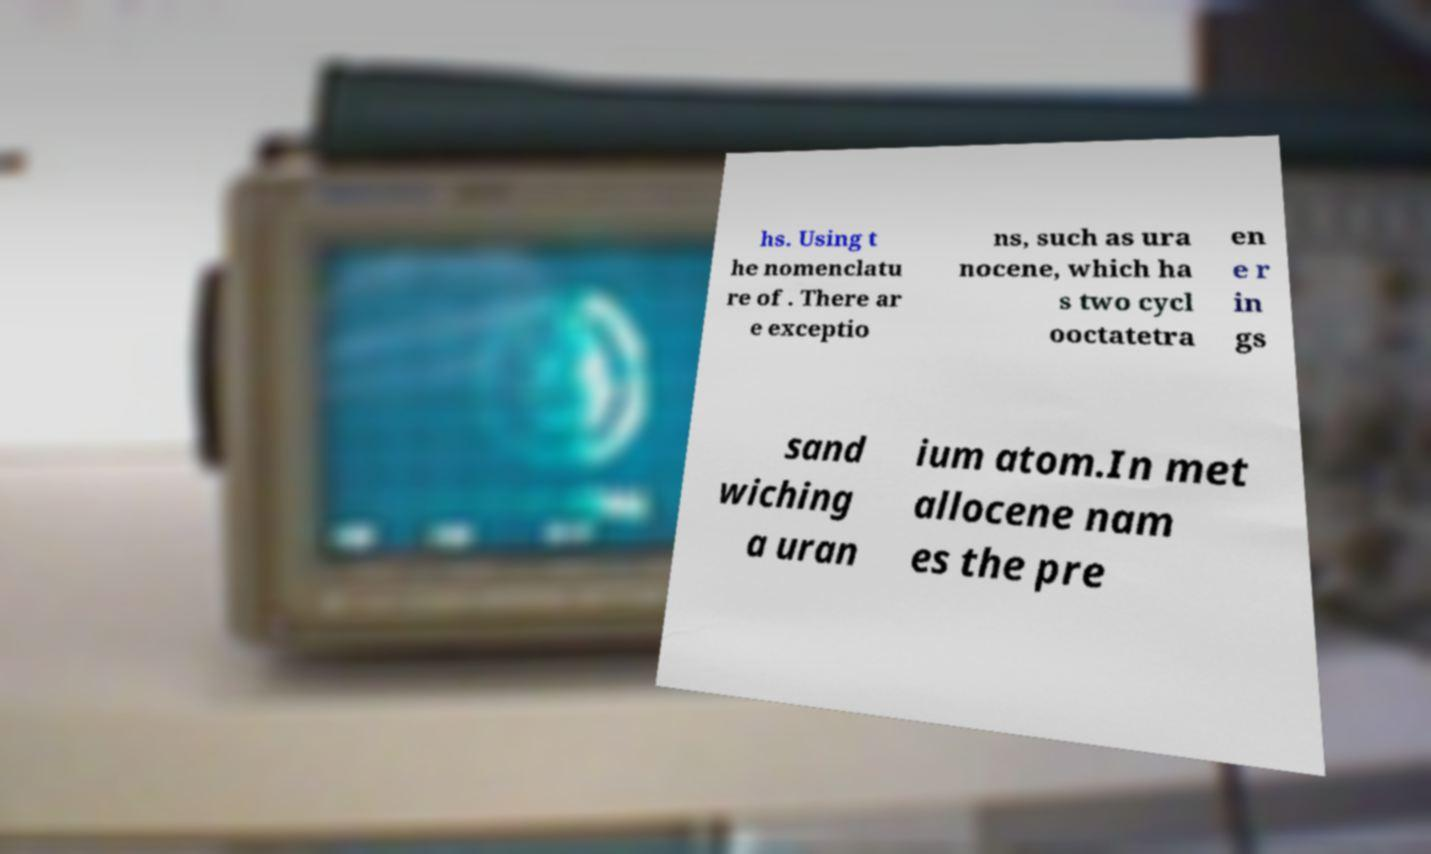Please read and relay the text visible in this image. What does it say? hs. Using t he nomenclatu re of . There ar e exceptio ns, such as ura nocene, which ha s two cycl ooctatetra en e r in gs sand wiching a uran ium atom.In met allocene nam es the pre 